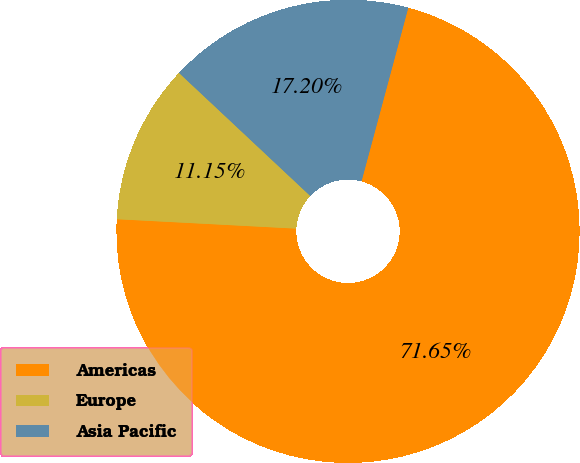Convert chart to OTSL. <chart><loc_0><loc_0><loc_500><loc_500><pie_chart><fcel>Americas<fcel>Europe<fcel>Asia Pacific<nl><fcel>71.64%<fcel>11.15%<fcel>17.2%<nl></chart> 